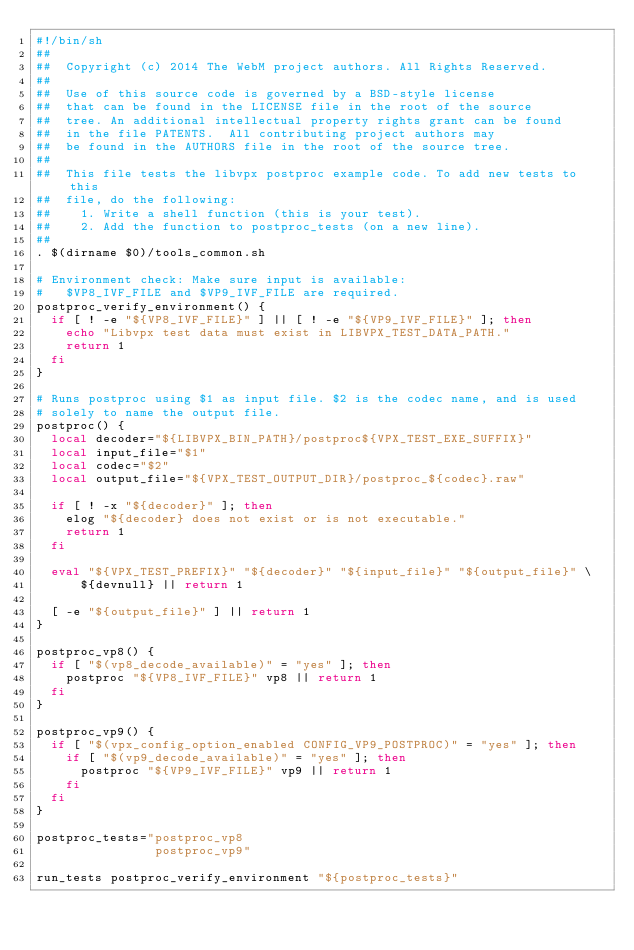<code> <loc_0><loc_0><loc_500><loc_500><_Bash_>#!/bin/sh
##
##  Copyright (c) 2014 The WebM project authors. All Rights Reserved.
##
##  Use of this source code is governed by a BSD-style license
##  that can be found in the LICENSE file in the root of the source
##  tree. An additional intellectual property rights grant can be found
##  in the file PATENTS.  All contributing project authors may
##  be found in the AUTHORS file in the root of the source tree.
##
##  This file tests the libvpx postproc example code. To add new tests to this
##  file, do the following:
##    1. Write a shell function (this is your test).
##    2. Add the function to postproc_tests (on a new line).
##
. $(dirname $0)/tools_common.sh

# Environment check: Make sure input is available:
#   $VP8_IVF_FILE and $VP9_IVF_FILE are required.
postproc_verify_environment() {
  if [ ! -e "${VP8_IVF_FILE}" ] || [ ! -e "${VP9_IVF_FILE}" ]; then
    echo "Libvpx test data must exist in LIBVPX_TEST_DATA_PATH."
    return 1
  fi
}

# Runs postproc using $1 as input file. $2 is the codec name, and is used
# solely to name the output file.
postproc() {
  local decoder="${LIBVPX_BIN_PATH}/postproc${VPX_TEST_EXE_SUFFIX}"
  local input_file="$1"
  local codec="$2"
  local output_file="${VPX_TEST_OUTPUT_DIR}/postproc_${codec}.raw"

  if [ ! -x "${decoder}" ]; then
    elog "${decoder} does not exist or is not executable."
    return 1
  fi

  eval "${VPX_TEST_PREFIX}" "${decoder}" "${input_file}" "${output_file}" \
      ${devnull} || return 1

  [ -e "${output_file}" ] || return 1
}

postproc_vp8() {
  if [ "$(vp8_decode_available)" = "yes" ]; then
    postproc "${VP8_IVF_FILE}" vp8 || return 1
  fi
}

postproc_vp9() {
  if [ "$(vpx_config_option_enabled CONFIG_VP9_POSTPROC)" = "yes" ]; then
    if [ "$(vp9_decode_available)" = "yes" ]; then
      postproc "${VP9_IVF_FILE}" vp9 || return 1
    fi
  fi
}

postproc_tests="postproc_vp8
                postproc_vp9"

run_tests postproc_verify_environment "${postproc_tests}"
</code> 